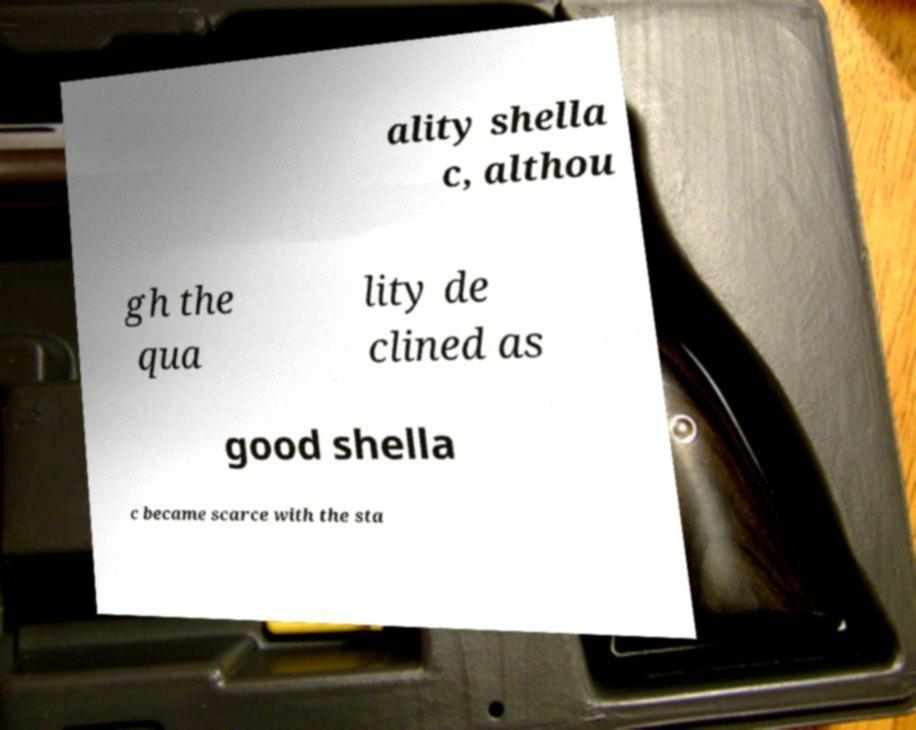Please identify and transcribe the text found in this image. ality shella c, althou gh the qua lity de clined as good shella c became scarce with the sta 